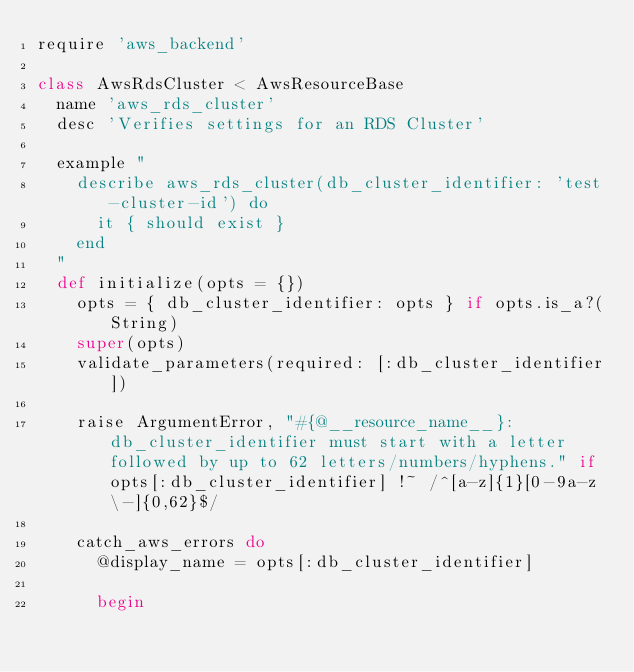<code> <loc_0><loc_0><loc_500><loc_500><_Ruby_>require 'aws_backend'

class AwsRdsCluster < AwsResourceBase
  name 'aws_rds_cluster'
  desc 'Verifies settings for an RDS Cluster'

  example "
    describe aws_rds_cluster(db_cluster_identifier: 'test-cluster-id') do
      it { should exist }
    end
  "
  def initialize(opts = {})
    opts = { db_cluster_identifier: opts } if opts.is_a?(String)
    super(opts)
    validate_parameters(required: [:db_cluster_identifier])

    raise ArgumentError, "#{@__resource_name__}: db_cluster_identifier must start with a letter followed by up to 62 letters/numbers/hyphens." if opts[:db_cluster_identifier] !~ /^[a-z]{1}[0-9a-z\-]{0,62}$/

    catch_aws_errors do
      @display_name = opts[:db_cluster_identifier]

      begin</code> 